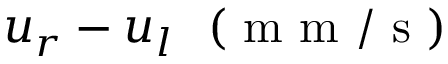Convert formula to latex. <formula><loc_0><loc_0><loc_500><loc_500>u _ { r } - u _ { l } ( m m / s )</formula> 